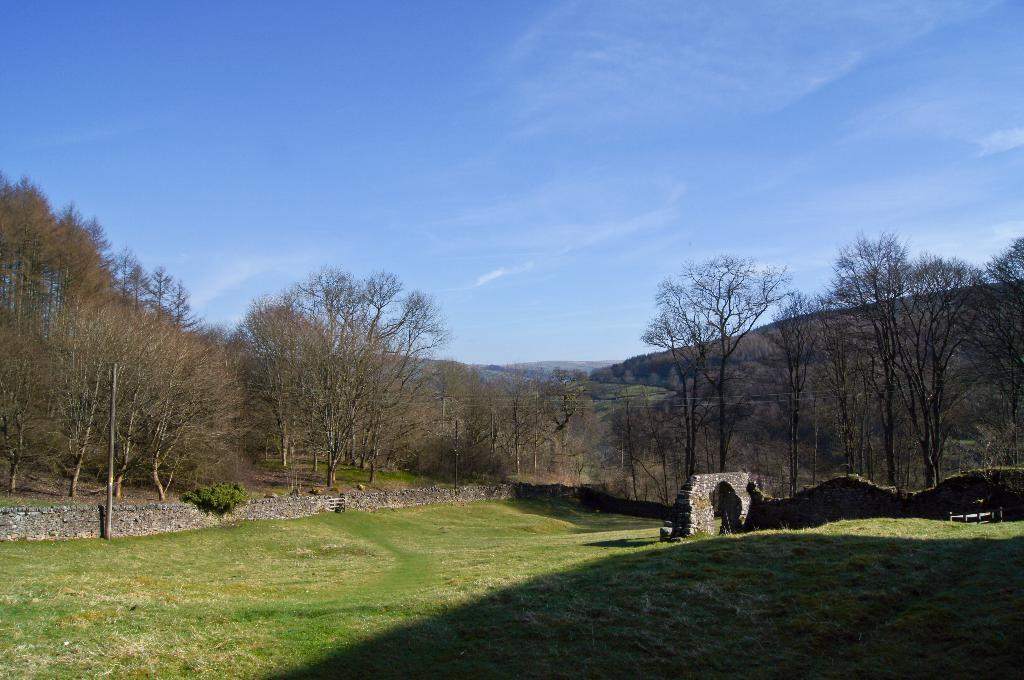What type of vegetation can be seen in the image? There are plants and trees in the image. What type of structures are present in the image? There are walls in the image. What natural landmarks can be seen in the image? There are mountains visible in the image. What part of the natural environment is visible in the image? The sky is visible in the image. What type of fruit is hanging from the trees in the image? There is no fruit visible on the trees in the image. What type of skirt is being worn by the mountain in the image? There are no skirts or people present in the image, and the mountain is a natural landmark. 